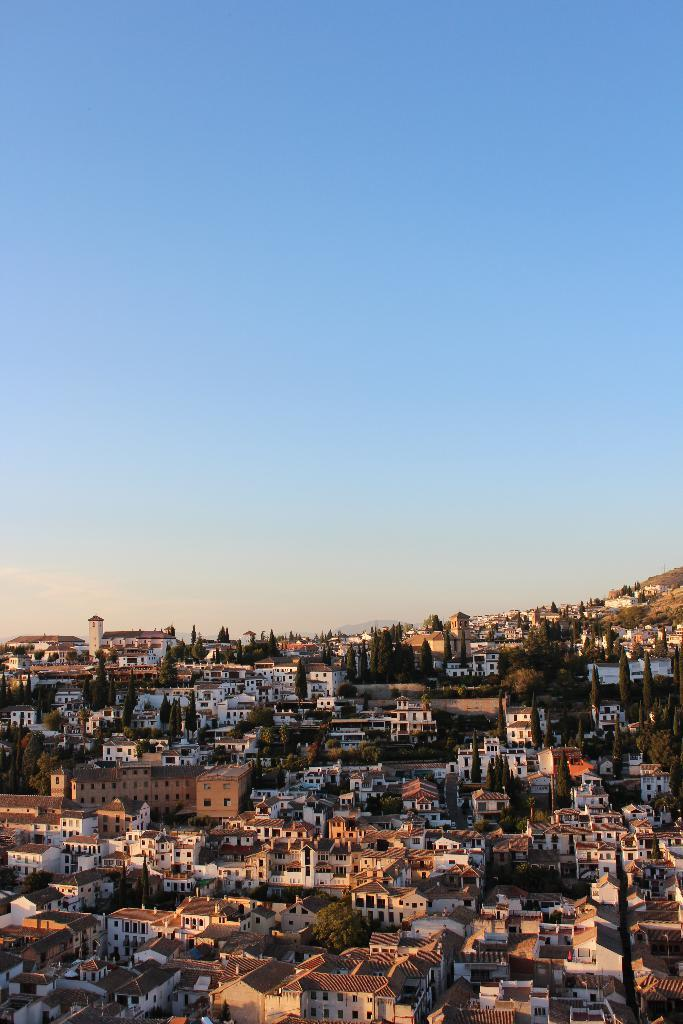What type of view is shown in the image? The image is an aerial view. What can be seen in the sky in the image? There is sky visible in the image, and clouds are present in the sky. What type of natural features are present in the image? There are hills and trees in the image. What type of man-made structures are present in the image? There are buildings in the image. How many cacti can be seen in the image? There are no cacti present in the image. What type of animal is grazing on the hills in the image? There are no animals visible in the image, including yaks. 